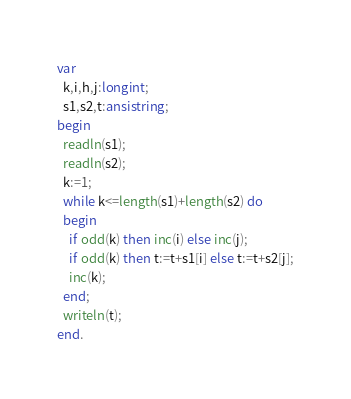Convert code to text. <code><loc_0><loc_0><loc_500><loc_500><_Pascal_>var
  k,i,h,j:longint;
  s1,s2,t:ansistring;
begin
  readln(s1);
  readln(s2);
  k:=1;
  while k<=length(s1)+length(s2) do
  begin
    if odd(k) then inc(i) else inc(j);
    if odd(k) then t:=t+s1[i] else t:=t+s2[j];
    inc(k);
  end;
  writeln(t);
end.</code> 